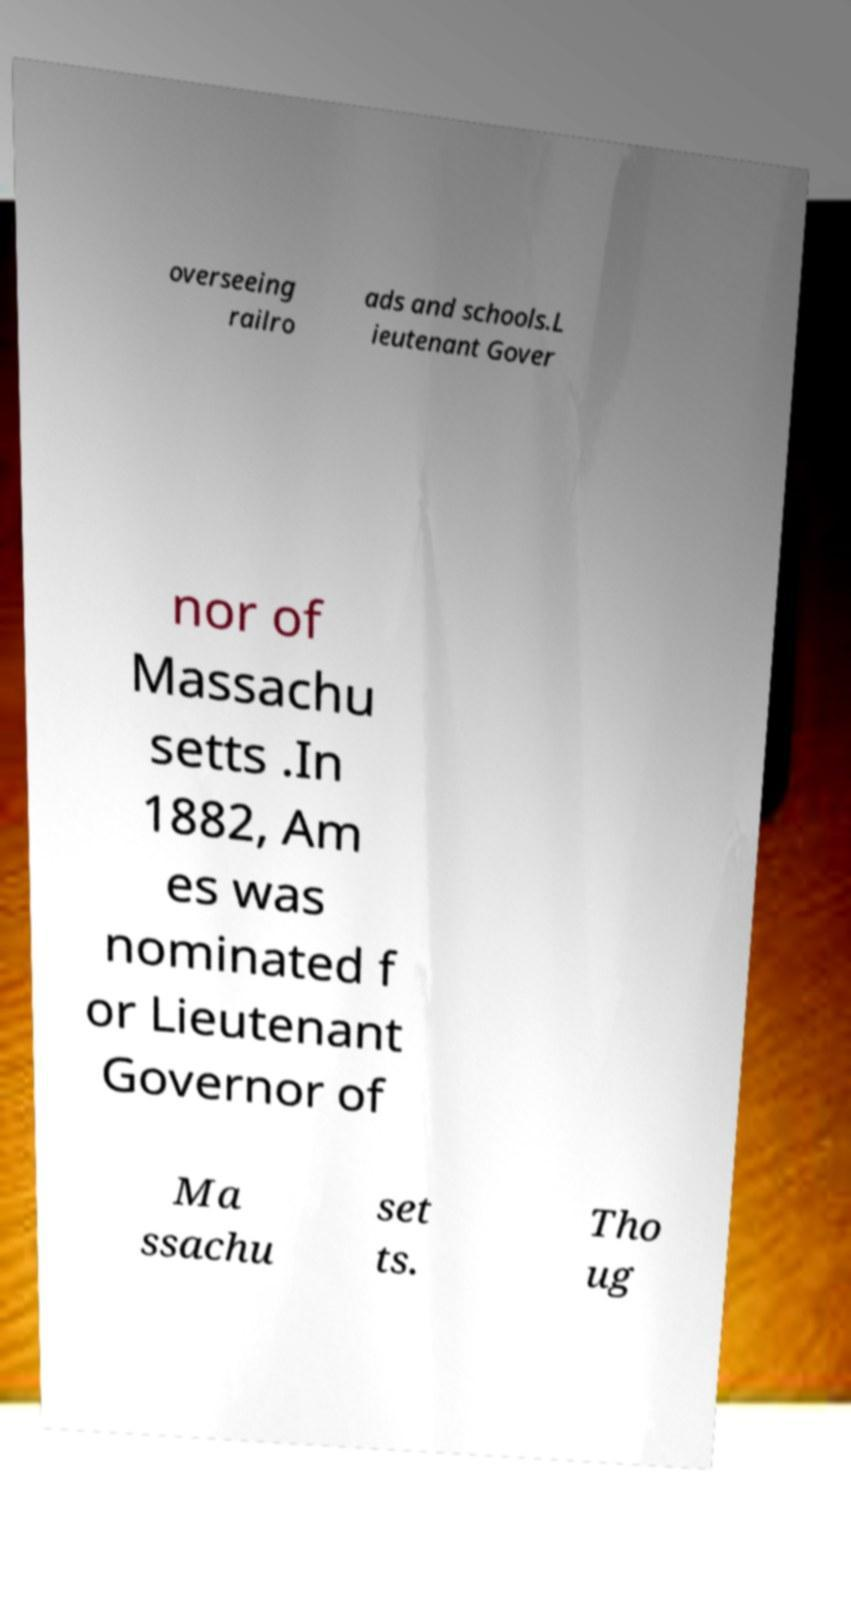Please identify and transcribe the text found in this image. overseeing railro ads and schools.L ieutenant Gover nor of Massachu setts .In 1882, Am es was nominated f or Lieutenant Governor of Ma ssachu set ts. Tho ug 